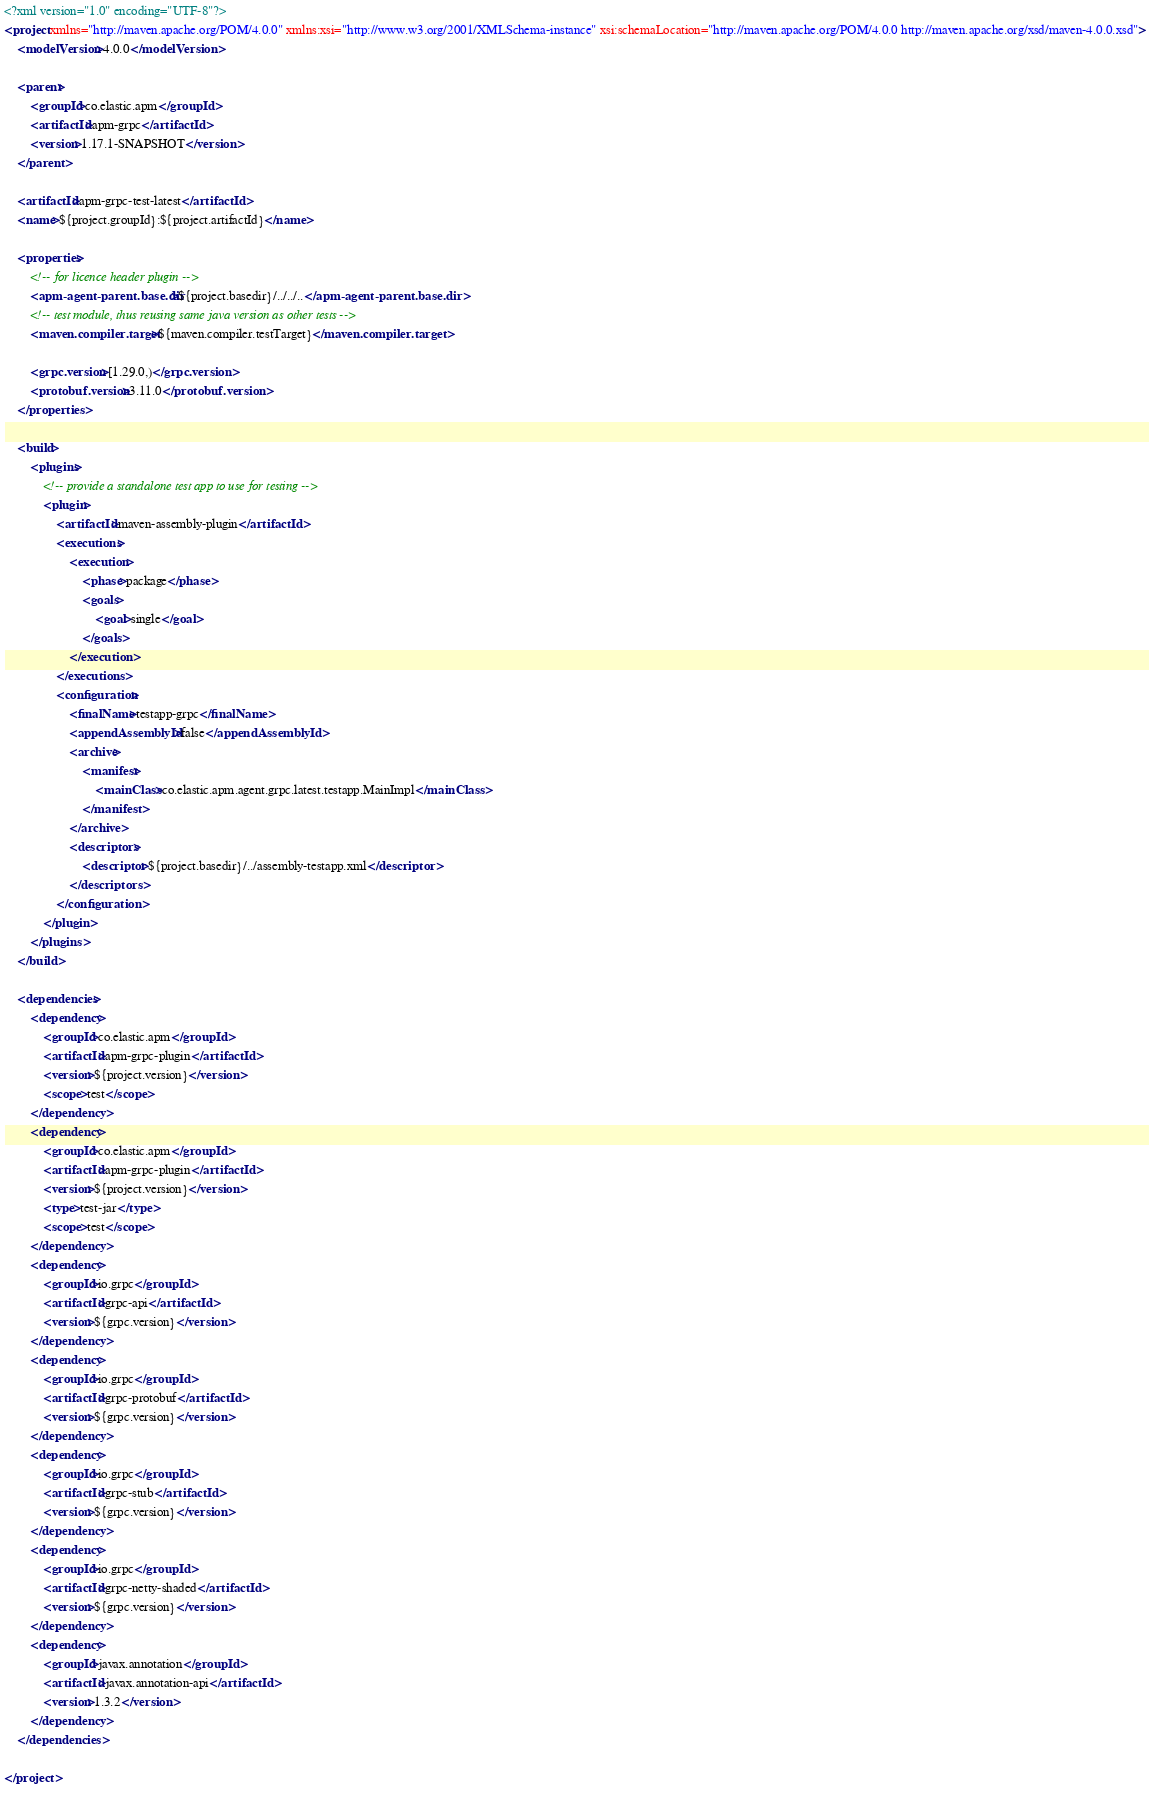<code> <loc_0><loc_0><loc_500><loc_500><_XML_><?xml version="1.0" encoding="UTF-8"?>
<project xmlns="http://maven.apache.org/POM/4.0.0" xmlns:xsi="http://www.w3.org/2001/XMLSchema-instance" xsi:schemaLocation="http://maven.apache.org/POM/4.0.0 http://maven.apache.org/xsd/maven-4.0.0.xsd">
    <modelVersion>4.0.0</modelVersion>

    <parent>
        <groupId>co.elastic.apm</groupId>
        <artifactId>apm-grpc</artifactId>
        <version>1.17.1-SNAPSHOT</version>
    </parent>

    <artifactId>apm-grpc-test-latest</artifactId>
    <name>${project.groupId}:${project.artifactId}</name>

    <properties>
        <!-- for licence header plugin -->
        <apm-agent-parent.base.dir>${project.basedir}/../../..</apm-agent-parent.base.dir>
        <!-- test module, thus reusing same java version as other tests -->
        <maven.compiler.target>${maven.compiler.testTarget}</maven.compiler.target>

        <grpc.version>[1.29.0,)</grpc.version>
        <protobuf.version>3.11.0</protobuf.version>
    </properties>

    <build>
        <plugins>
            <!-- provide a standalone test app to use for testing -->
            <plugin>
                <artifactId>maven-assembly-plugin</artifactId>
                <executions>
                    <execution>
                        <phase>package</phase>
                        <goals>
                            <goal>single</goal>
                        </goals>
                    </execution>
                </executions>
                <configuration>
                    <finalName>testapp-grpc</finalName>
                    <appendAssemblyId>false</appendAssemblyId>
                    <archive>
                        <manifest>
                            <mainClass>co.elastic.apm.agent.grpc.latest.testapp.MainImpl</mainClass>
                        </manifest>
                    </archive>
                    <descriptors>
                        <descriptor>${project.basedir}/../assembly-testapp.xml</descriptor>
                    </descriptors>
                </configuration>
            </plugin>
        </plugins>
    </build>

    <dependencies>
        <dependency>
            <groupId>co.elastic.apm</groupId>
            <artifactId>apm-grpc-plugin</artifactId>
            <version>${project.version}</version>
            <scope>test</scope>
        </dependency>
        <dependency>
            <groupId>co.elastic.apm</groupId>
            <artifactId>apm-grpc-plugin</artifactId>
            <version>${project.version}</version>
            <type>test-jar</type>
            <scope>test</scope>
        </dependency>
        <dependency>
            <groupId>io.grpc</groupId>
            <artifactId>grpc-api</artifactId>
            <version>${grpc.version}</version>
        </dependency>
        <dependency>
            <groupId>io.grpc</groupId>
            <artifactId>grpc-protobuf</artifactId>
            <version>${grpc.version}</version>
        </dependency>
        <dependency>
            <groupId>io.grpc</groupId>
            <artifactId>grpc-stub</artifactId>
            <version>${grpc.version}</version>
        </dependency>
        <dependency>
            <groupId>io.grpc</groupId>
            <artifactId>grpc-netty-shaded</artifactId>
            <version>${grpc.version}</version>
        </dependency>
        <dependency>
            <groupId>javax.annotation</groupId>
            <artifactId>javax.annotation-api</artifactId>
            <version>1.3.2</version>
        </dependency>
    </dependencies>

</project>
</code> 